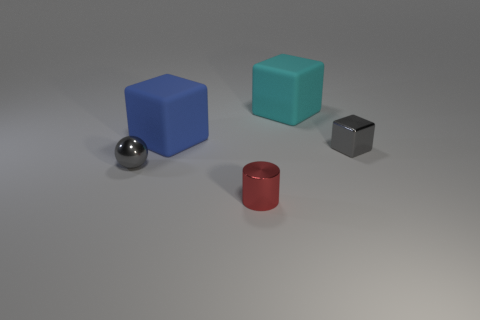Add 5 blue objects. How many objects exist? 10 Subtract all cylinders. How many objects are left? 4 Add 2 tiny brown objects. How many tiny brown objects exist? 2 Subtract 0 red blocks. How many objects are left? 5 Subtract all blue matte objects. Subtract all tiny metallic things. How many objects are left? 1 Add 4 matte blocks. How many matte blocks are left? 6 